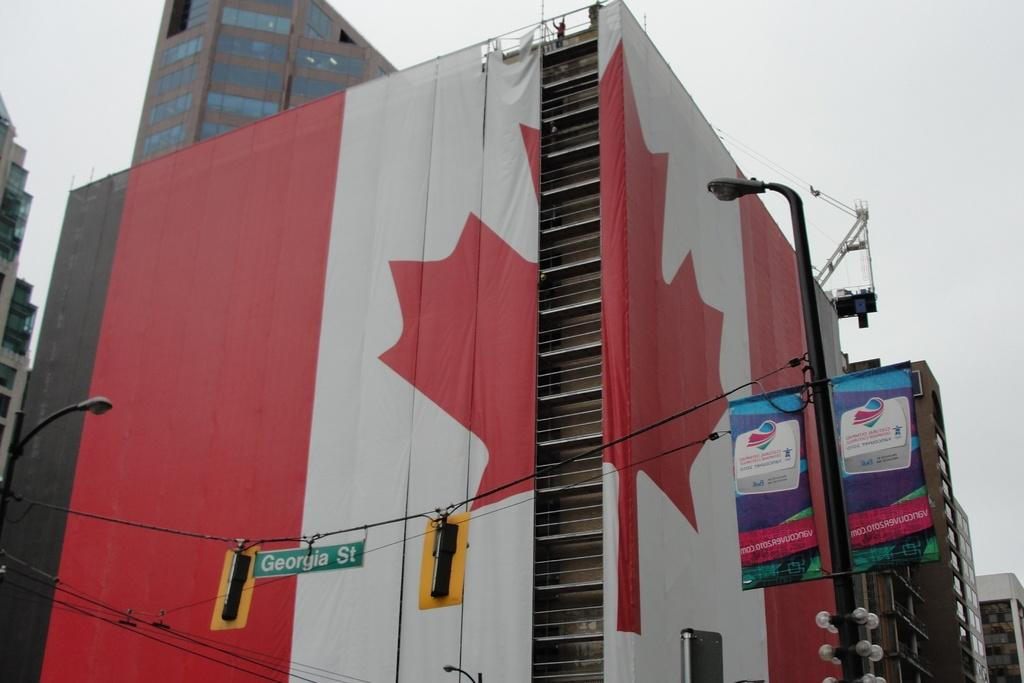Provide a one-sentence caption for the provided image. A multi-story building wrapped in two pieces of the Canadian flag in front of a red light on Georgia Street. 